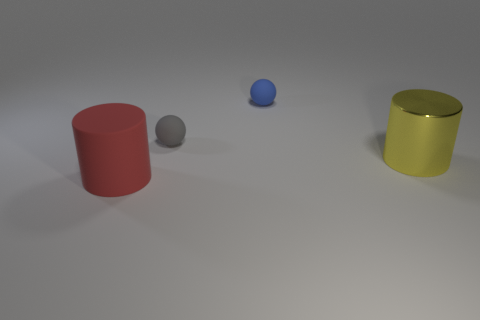Is there anything else that has the same material as the big yellow thing?
Make the answer very short. No. What is the shape of the object that is the same size as the gray matte ball?
Offer a terse response. Sphere. What number of things are either blue balls that are on the right side of the big red thing or objects to the left of the yellow cylinder?
Provide a short and direct response. 3. Is the number of tiny gray matte balls less than the number of large rubber balls?
Keep it short and to the point. No. There is another object that is the same size as the red rubber object; what is its material?
Keep it short and to the point. Metal. Does the object left of the gray object have the same size as the rubber ball in front of the blue ball?
Provide a short and direct response. No. Is there a tiny gray ball that has the same material as the gray object?
Offer a terse response. No. What number of things are either big cylinders that are in front of the big yellow cylinder or blue shiny objects?
Offer a terse response. 1. Is the object that is in front of the yellow object made of the same material as the yellow object?
Keep it short and to the point. No. Is the shape of the large yellow object the same as the large matte object?
Keep it short and to the point. Yes. 